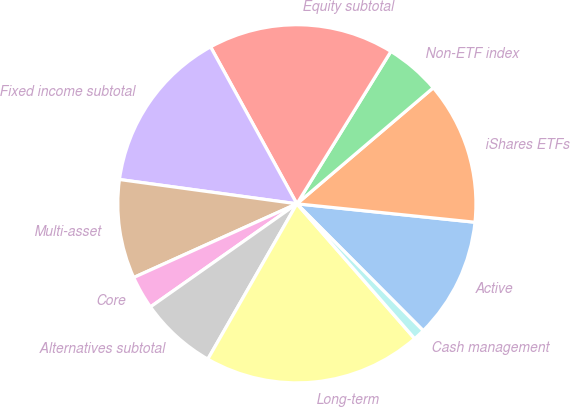<chart> <loc_0><loc_0><loc_500><loc_500><pie_chart><fcel>Active<fcel>iShares ETFs<fcel>Non-ETF index<fcel>Equity subtotal<fcel>Fixed income subtotal<fcel>Multi-asset<fcel>Core<fcel>Alternatives subtotal<fcel>Long-term<fcel>Cash management<nl><fcel>10.89%<fcel>12.86%<fcel>4.98%<fcel>16.8%<fcel>14.83%<fcel>8.92%<fcel>3.01%<fcel>6.95%<fcel>19.71%<fcel>1.04%<nl></chart> 